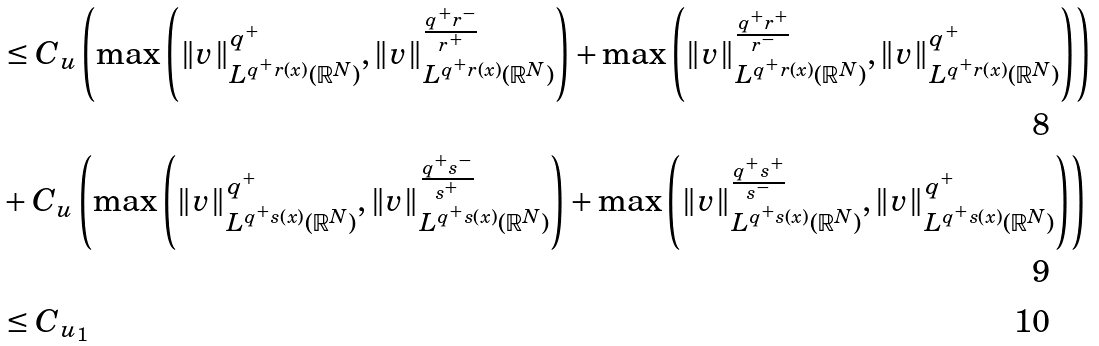<formula> <loc_0><loc_0><loc_500><loc_500>& \leq C _ { u } \left ( \max \left ( \| v \| ^ { q ^ { + } } _ { L ^ { q ^ { + } r ( x ) } ( \mathbb { R } ^ { N } ) } , \| v \| ^ { \frac { q ^ { + } r ^ { - } } { r ^ { + } } } _ { L ^ { q ^ { + } r ( x ) } ( \mathbb { R } ^ { N } ) } \right ) + \max \left ( \| v \| ^ { \frac { q ^ { + } r ^ { + } } { r ^ { - } } } _ { L ^ { q ^ { + } r ( x ) } ( \mathbb { R } ^ { N } ) } , \| v \| ^ { q ^ { + } } _ { L ^ { q ^ { + } r ( x ) } ( \mathbb { R } ^ { N } ) } \right ) \right ) \\ & + C _ { u } \left ( \max \left ( \| v \| ^ { q ^ { + } } _ { L ^ { q ^ { + } s ( x ) } ( \mathbb { R } ^ { N } ) } , \| v \| ^ { \frac { q ^ { + } s ^ { - } } { s ^ { + } } } _ { L ^ { q ^ { + } s ( x ) } ( \mathbb { R } ^ { N } ) } \right ) + \max \left ( \| v \| ^ { \frac { q ^ { + } s ^ { + } } { s ^ { - } } } _ { L ^ { q ^ { + } s ( x ) } ( \mathbb { R } ^ { N } ) } , \| v \| ^ { q ^ { + } } _ { L ^ { q ^ { + } s ( x ) } ( \mathbb { R } ^ { N } ) } \right ) \right ) \\ & \leq C _ { u _ { 1 } }</formula> 